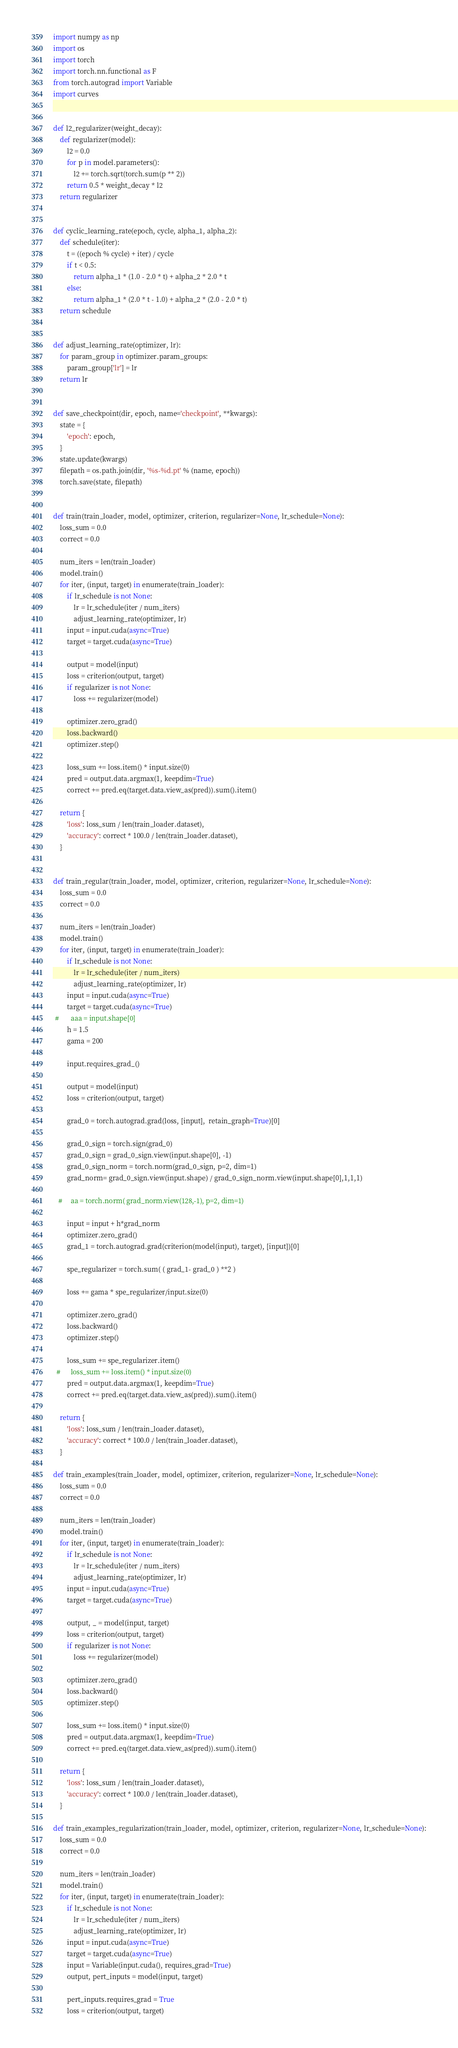<code> <loc_0><loc_0><loc_500><loc_500><_Python_>import numpy as np
import os
import torch
import torch.nn.functional as F
from torch.autograd import Variable
import curves


def l2_regularizer(weight_decay):
    def regularizer(model):
        l2 = 0.0
        for p in model.parameters():
            l2 += torch.sqrt(torch.sum(p ** 2))
        return 0.5 * weight_decay * l2
    return regularizer


def cyclic_learning_rate(epoch, cycle, alpha_1, alpha_2):
    def schedule(iter):
        t = ((epoch % cycle) + iter) / cycle
        if t < 0.5:
            return alpha_1 * (1.0 - 2.0 * t) + alpha_2 * 2.0 * t
        else:
            return alpha_1 * (2.0 * t - 1.0) + alpha_2 * (2.0 - 2.0 * t)
    return schedule


def adjust_learning_rate(optimizer, lr):
    for param_group in optimizer.param_groups:
        param_group['lr'] = lr
    return lr


def save_checkpoint(dir, epoch, name='checkpoint', **kwargs):
    state = {
        'epoch': epoch,
    }
    state.update(kwargs)
    filepath = os.path.join(dir, '%s-%d.pt' % (name, epoch))
    torch.save(state, filepath)


def train(train_loader, model, optimizer, criterion, regularizer=None, lr_schedule=None):
    loss_sum = 0.0
    correct = 0.0

    num_iters = len(train_loader)
    model.train()
    for iter, (input, target) in enumerate(train_loader):
        if lr_schedule is not None:
            lr = lr_schedule(iter / num_iters)
            adjust_learning_rate(optimizer, lr)
        input = input.cuda(async=True)
        target = target.cuda(async=True)

        output = model(input)
        loss = criterion(output, target)
        if regularizer is not None:
            loss += regularizer(model)

        optimizer.zero_grad()
        loss.backward()
        optimizer.step()

        loss_sum += loss.item() * input.size(0)
        pred = output.data.argmax(1, keepdim=True)
        correct += pred.eq(target.data.view_as(pred)).sum().item()

    return {
        'loss': loss_sum / len(train_loader.dataset),
        'accuracy': correct * 100.0 / len(train_loader.dataset),
    }


def train_regular(train_loader, model, optimizer, criterion, regularizer=None, lr_schedule=None):
    loss_sum = 0.0
    correct = 0.0

    num_iters = len(train_loader)
    model.train()
    for iter, (input, target) in enumerate(train_loader):
        if lr_schedule is not None:
            lr = lr_schedule(iter / num_iters)
            adjust_learning_rate(optimizer, lr)
        input = input.cuda(async=True)
        target = target.cuda(async=True)
 #       aaa = input.shape[0]
        h = 1.5
        gama = 200

        input.requires_grad_()

        output = model(input)
        loss = criterion(output, target)

        grad_0 = torch.autograd.grad(loss, [input],  retain_graph=True)[0]

        grad_0_sign = torch.sign(grad_0)
        grad_0_sign = grad_0_sign.view(input.shape[0], -1)
        grad_0_sign_norm = torch.norm(grad_0_sign, p=2, dim=1)
        grad_norm= grad_0_sign.view(input.shape) / grad_0_sign_norm.view(input.shape[0],1,1,1)

   #     aa = torch.norm( grad_norm.view(128,-1), p=2, dim=1)

        input = input + h*grad_norm
        optimizer.zero_grad()
        grad_1 = torch.autograd.grad(criterion(model(input), target), [input])[0]

        spe_regularizer = torch.sum( ( grad_1- grad_0 ) **2 )

        loss += gama * spe_regularizer/input.size(0)

        optimizer.zero_grad()
        loss.backward()
        optimizer.step()

        loss_sum += spe_regularizer.item()
  #      loss_sum += loss.item() * input.size(0)
        pred = output.data.argmax(1, keepdim=True)
        correct += pred.eq(target.data.view_as(pred)).sum().item()

    return {
        'loss': loss_sum / len(train_loader.dataset),
        'accuracy': correct * 100.0 / len(train_loader.dataset),
    }

def train_examples(train_loader, model, optimizer, criterion, regularizer=None, lr_schedule=None):
    loss_sum = 0.0
    correct = 0.0

    num_iters = len(train_loader)
    model.train()
    for iter, (input, target) in enumerate(train_loader):
        if lr_schedule is not None:
            lr = lr_schedule(iter / num_iters)
            adjust_learning_rate(optimizer, lr)
        input = input.cuda(async=True)
        target = target.cuda(async=True)

        output, _ = model(input, target)
        loss = criterion(output, target)
        if regularizer is not None:
            loss += regularizer(model)

        optimizer.zero_grad()
        loss.backward()
        optimizer.step()

        loss_sum += loss.item() * input.size(0)
        pred = output.data.argmax(1, keepdim=True)
        correct += pred.eq(target.data.view_as(pred)).sum().item()

    return {
        'loss': loss_sum / len(train_loader.dataset),
        'accuracy': correct * 100.0 / len(train_loader.dataset),
    }

def train_examples_regularization(train_loader, model, optimizer, criterion, regularizer=None, lr_schedule=None):
    loss_sum = 0.0
    correct = 0.0

    num_iters = len(train_loader)
    model.train()
    for iter, (input, target) in enumerate(train_loader):
        if lr_schedule is not None:
            lr = lr_schedule(iter / num_iters)
            adjust_learning_rate(optimizer, lr)
        input = input.cuda(async=True)
        target = target.cuda(async=True)
        input = Variable(input.cuda(), requires_grad=True)
        output, pert_inputs = model(input, target)

        pert_inputs.requires_grad = True
        loss = criterion(output, target)</code> 